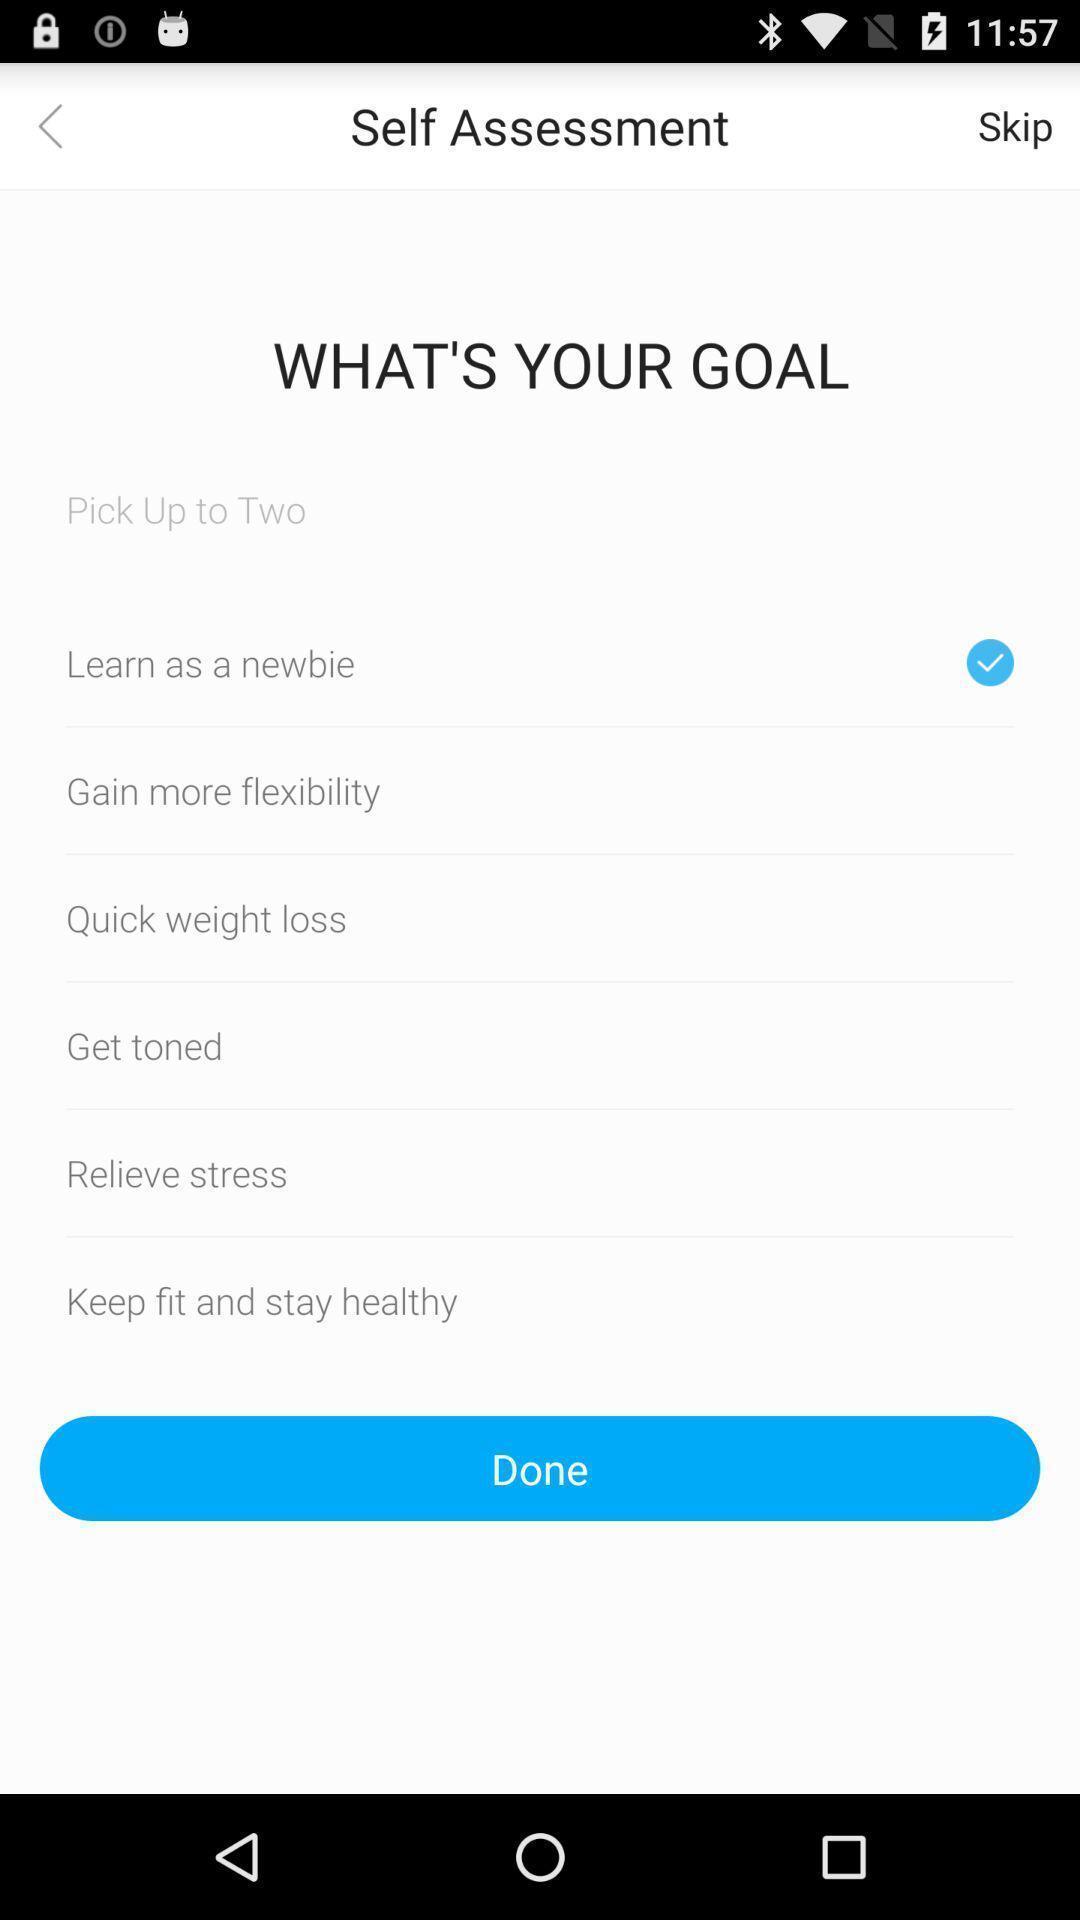Describe this image in words. Self assessment page displayed. 